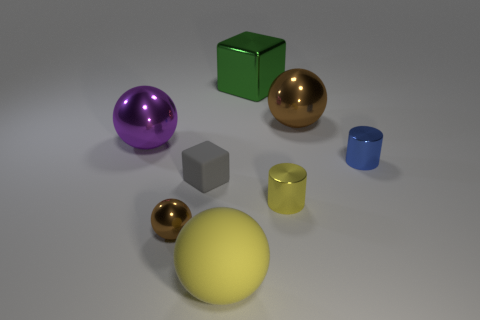Subtract all cyan blocks. How many brown spheres are left? 2 Subtract all tiny spheres. How many spheres are left? 3 Subtract all purple balls. How many balls are left? 3 Add 1 small purple shiny spheres. How many objects exist? 9 Subtract all cyan spheres. Subtract all green cubes. How many spheres are left? 4 Subtract all blocks. How many objects are left? 6 Subtract 0 brown blocks. How many objects are left? 8 Subtract all purple objects. Subtract all blue metallic cylinders. How many objects are left? 6 Add 3 tiny cylinders. How many tiny cylinders are left? 5 Add 7 small yellow objects. How many small yellow objects exist? 8 